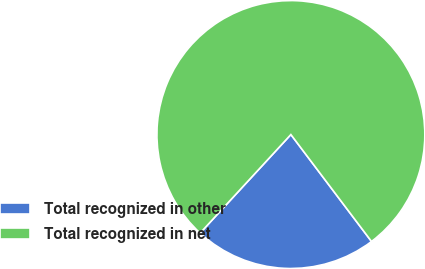Convert chart to OTSL. <chart><loc_0><loc_0><loc_500><loc_500><pie_chart><fcel>Total recognized in other<fcel>Total recognized in net<nl><fcel>22.13%<fcel>77.87%<nl></chart> 